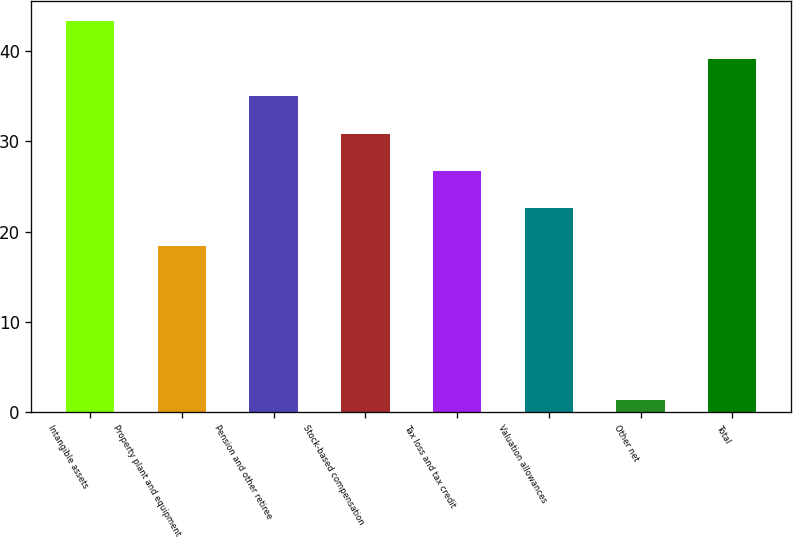Convert chart. <chart><loc_0><loc_0><loc_500><loc_500><bar_chart><fcel>Intangible assets<fcel>Property plant and equipment<fcel>Pension and other retiree<fcel>Stock-based compensation<fcel>Tax loss and tax credit<fcel>Valuation allowances<fcel>Other net<fcel>Total<nl><fcel>43.3<fcel>18.4<fcel>35<fcel>30.85<fcel>26.7<fcel>22.55<fcel>1.3<fcel>39.15<nl></chart> 